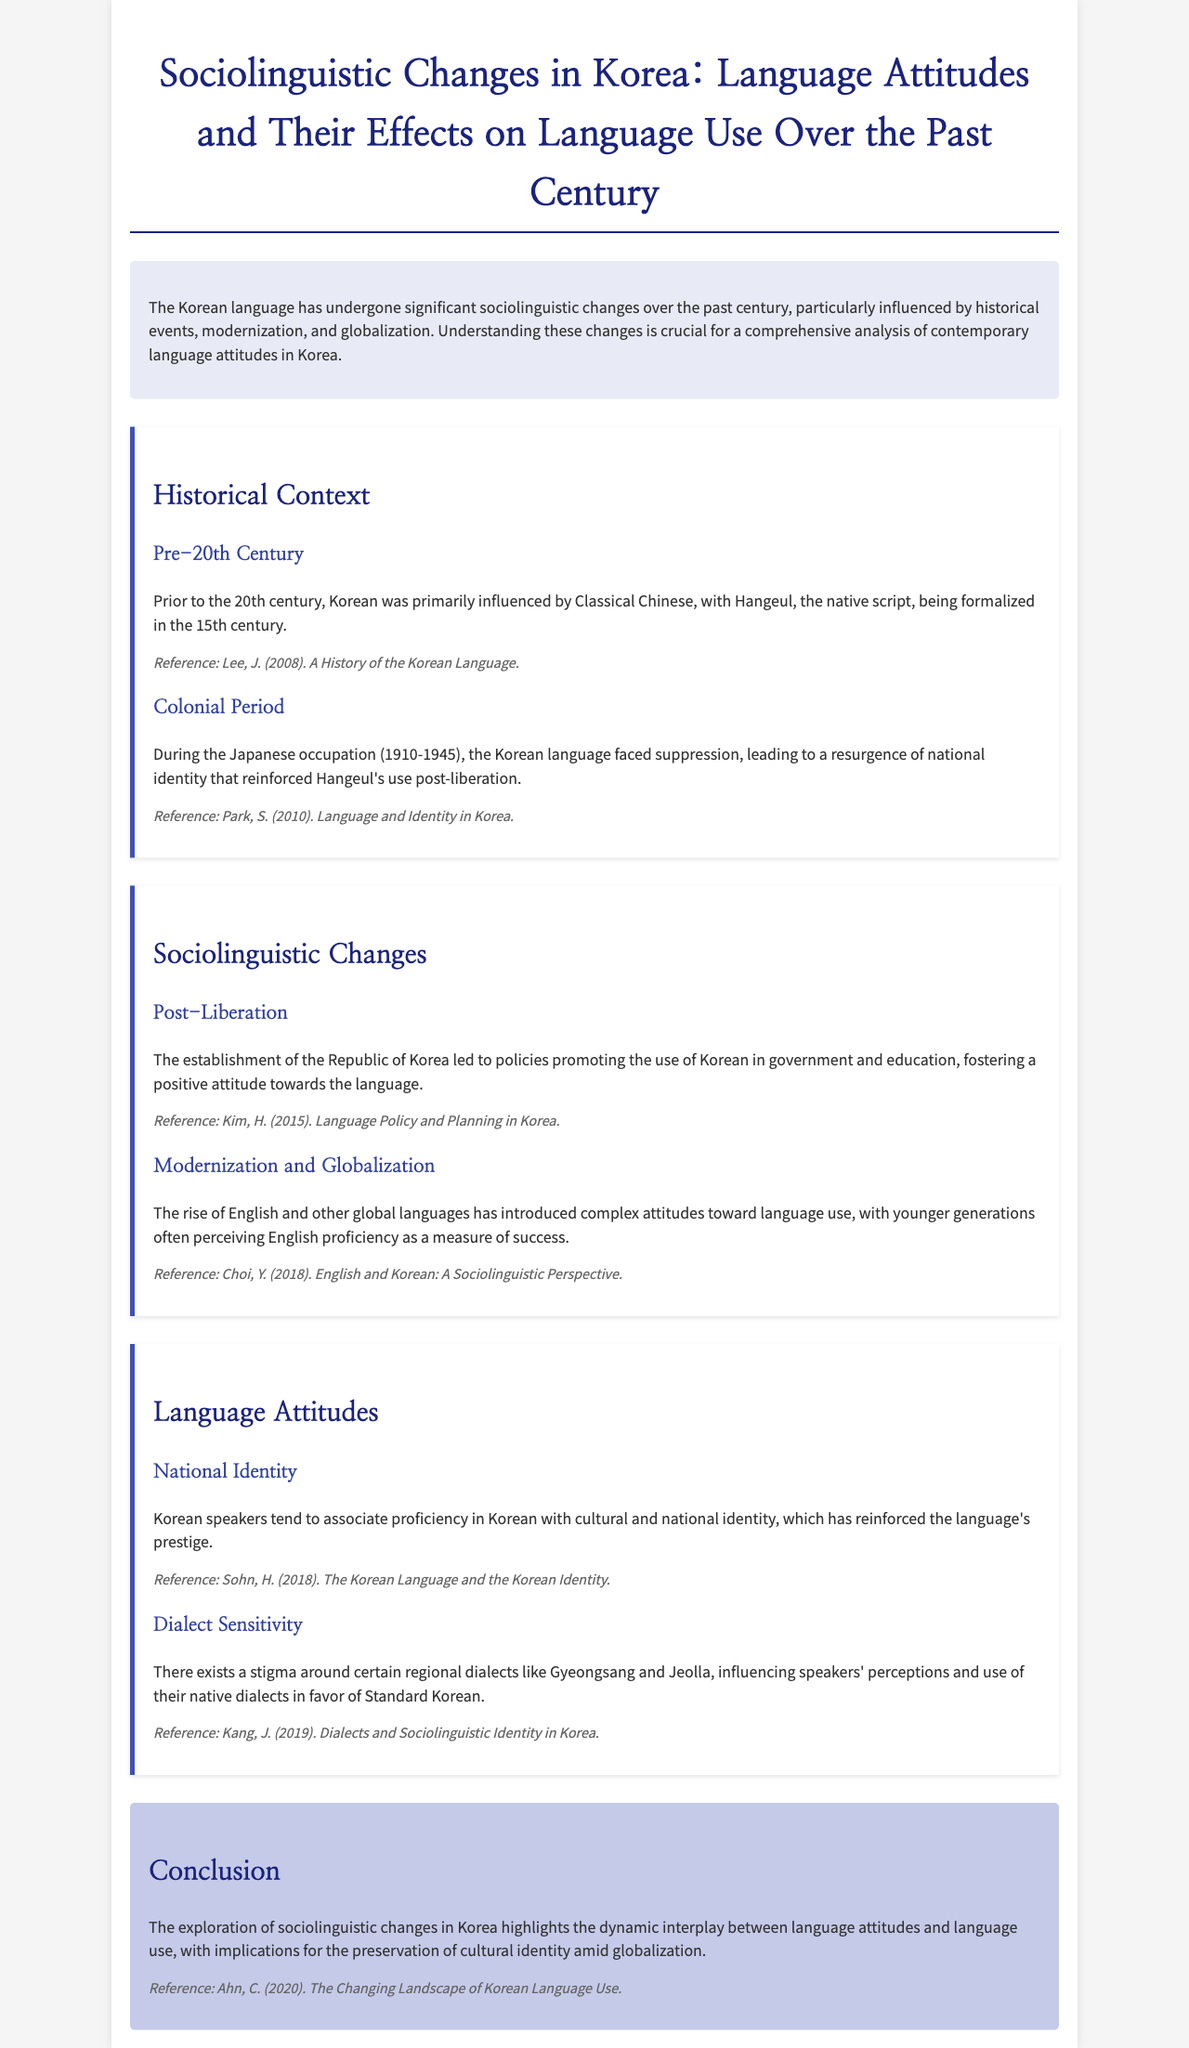What is the title of the report? The title provides the main subject matter of the document, which is about sociolinguistic changes in Korea.
Answer: Sociolinguistic Changes in Korea: Language Attitudes and Their Effects on Language Use Over the Past Century When was the Japanese occupation of Korea? The document provides a specific historical time period associated with the suppression of the Korean language.
Answer: 1910-1945 What script was formalized in the 15th century? This refers to the native writing system mentioned in the document's historical context.
Answer: Hangeul Which language's proficiency is perceived as a measure of success by younger generations? This reflects the influences of globalization on attitudes toward language use.
Answer: English What does proficiency in Korean associate with according to the document? This question seeks to highlight cultural and national identity connected to the Korean language.
Answer: Cultural and national identity What is the primary focus of the conclusion? The conclusion summarizes the overall exploration of the document's themes regarding language use and identity.
Answer: Dynamic interplay between language attitudes and language use How does the report describe regional dialect sensitivity? This question addresses how dialects affect speakers' perceptions of their native language.
Answer: Stigma around certain regional dialects Which reference discusses dialects and sociolinguistic identity? This question connects a specific reference to the section about dialect sensitivity.
Answer: Kang, J. (2019). Dialects and Sociolinguistic Identity in Korea 